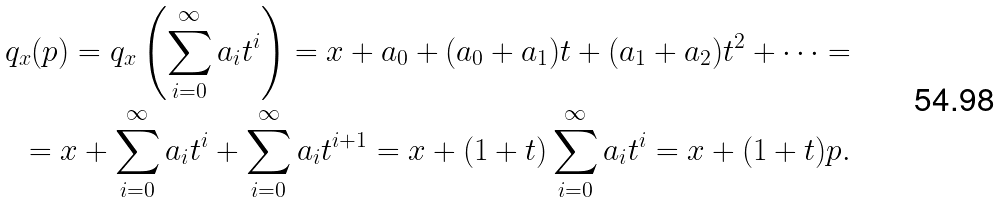Convert formula to latex. <formula><loc_0><loc_0><loc_500><loc_500>q _ { x } ( p ) = q _ { x } \left ( \sum _ { i = 0 } ^ { \infty } a _ { i } t ^ { i } \right ) = x + a _ { 0 } + ( a _ { 0 } + a _ { 1 } ) t + ( a _ { 1 } + a _ { 2 } ) t ^ { 2 } + \dots = \\ = x + \sum _ { i = 0 } ^ { \infty } a _ { i } t ^ { i } + \sum _ { i = 0 } ^ { \infty } a _ { i } t ^ { i + 1 } = x + ( 1 + t ) \sum _ { i = 0 } ^ { \infty } a _ { i } t ^ { i } = x + ( 1 + t ) p .</formula> 